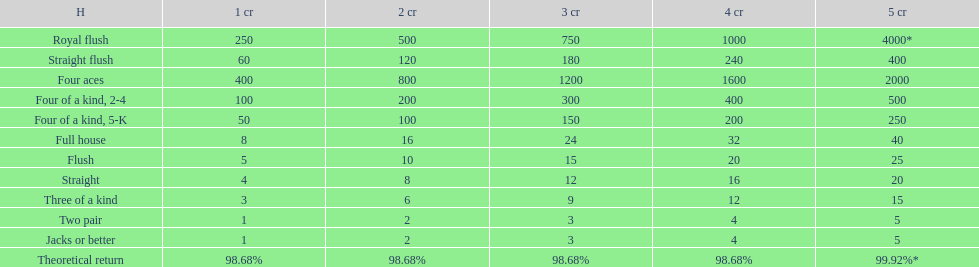The number of flush wins at one credit to equal one flush win at 5 credits. 5. 